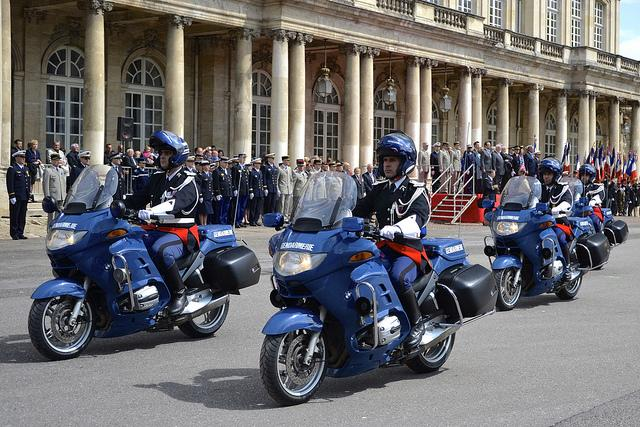What type of outfit are the men on the motorcycles wearing? Please explain your reasoning. uniform. The clothes the men are wearing are identical. 